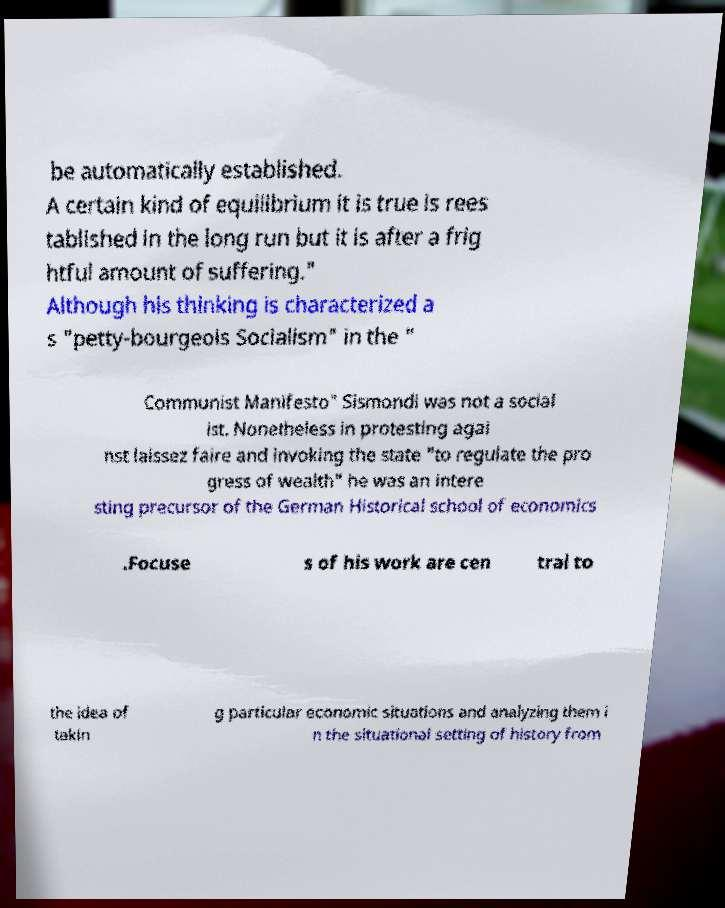What messages or text are displayed in this image? I need them in a readable, typed format. be automatically established. A certain kind of equilibrium it is true is rees tablished in the long run but it is after a frig htful amount of suffering." Although his thinking is characterized a s "petty-bourgeois Socialism" in the " Communist Manifesto" Sismondi was not a social ist. Nonetheless in protesting agai nst laissez faire and invoking the state "to regulate the pro gress of wealth" he was an intere sting precursor of the German Historical school of economics .Focuse s of his work are cen tral to the idea of takin g particular economic situations and analyzing them i n the situational setting of history from 